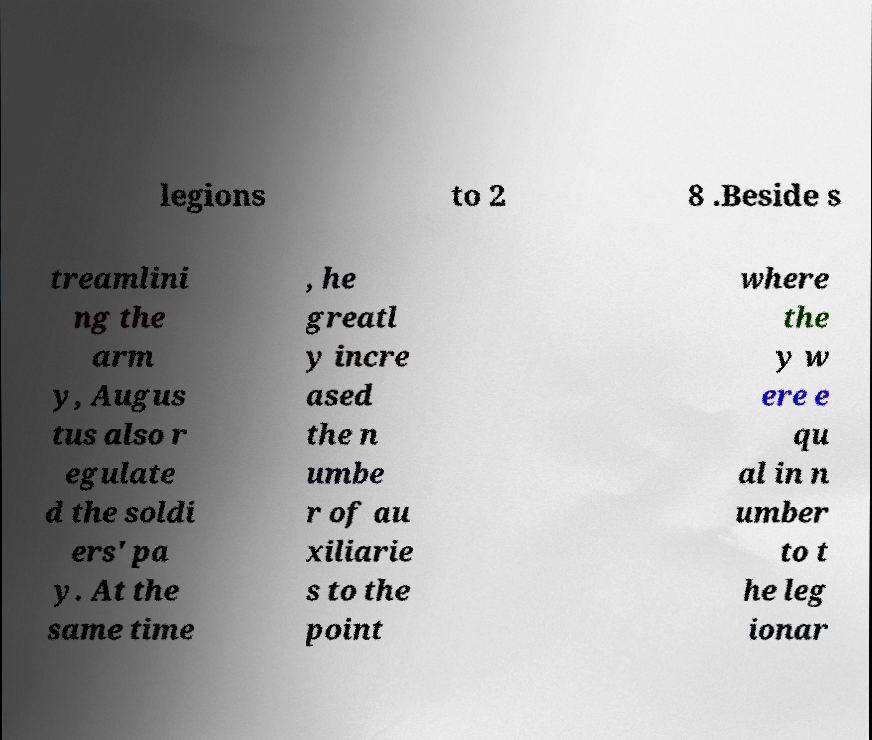Could you assist in decoding the text presented in this image and type it out clearly? legions to 2 8 .Beside s treamlini ng the arm y, Augus tus also r egulate d the soldi ers' pa y. At the same time , he greatl y incre ased the n umbe r of au xiliarie s to the point where the y w ere e qu al in n umber to t he leg ionar 